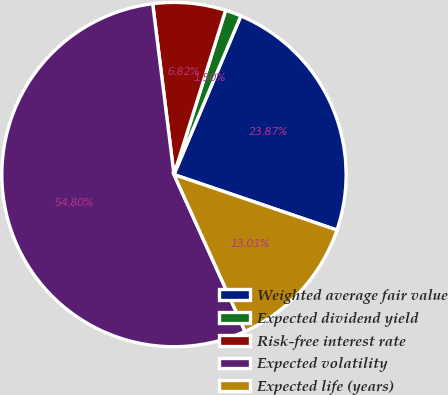<chart> <loc_0><loc_0><loc_500><loc_500><pie_chart><fcel>Weighted average fair value<fcel>Expected dividend yield<fcel>Risk-free interest rate<fcel>Expected volatility<fcel>Expected life (years)<nl><fcel>23.87%<fcel>1.5%<fcel>6.82%<fcel>54.79%<fcel>13.01%<nl></chart> 